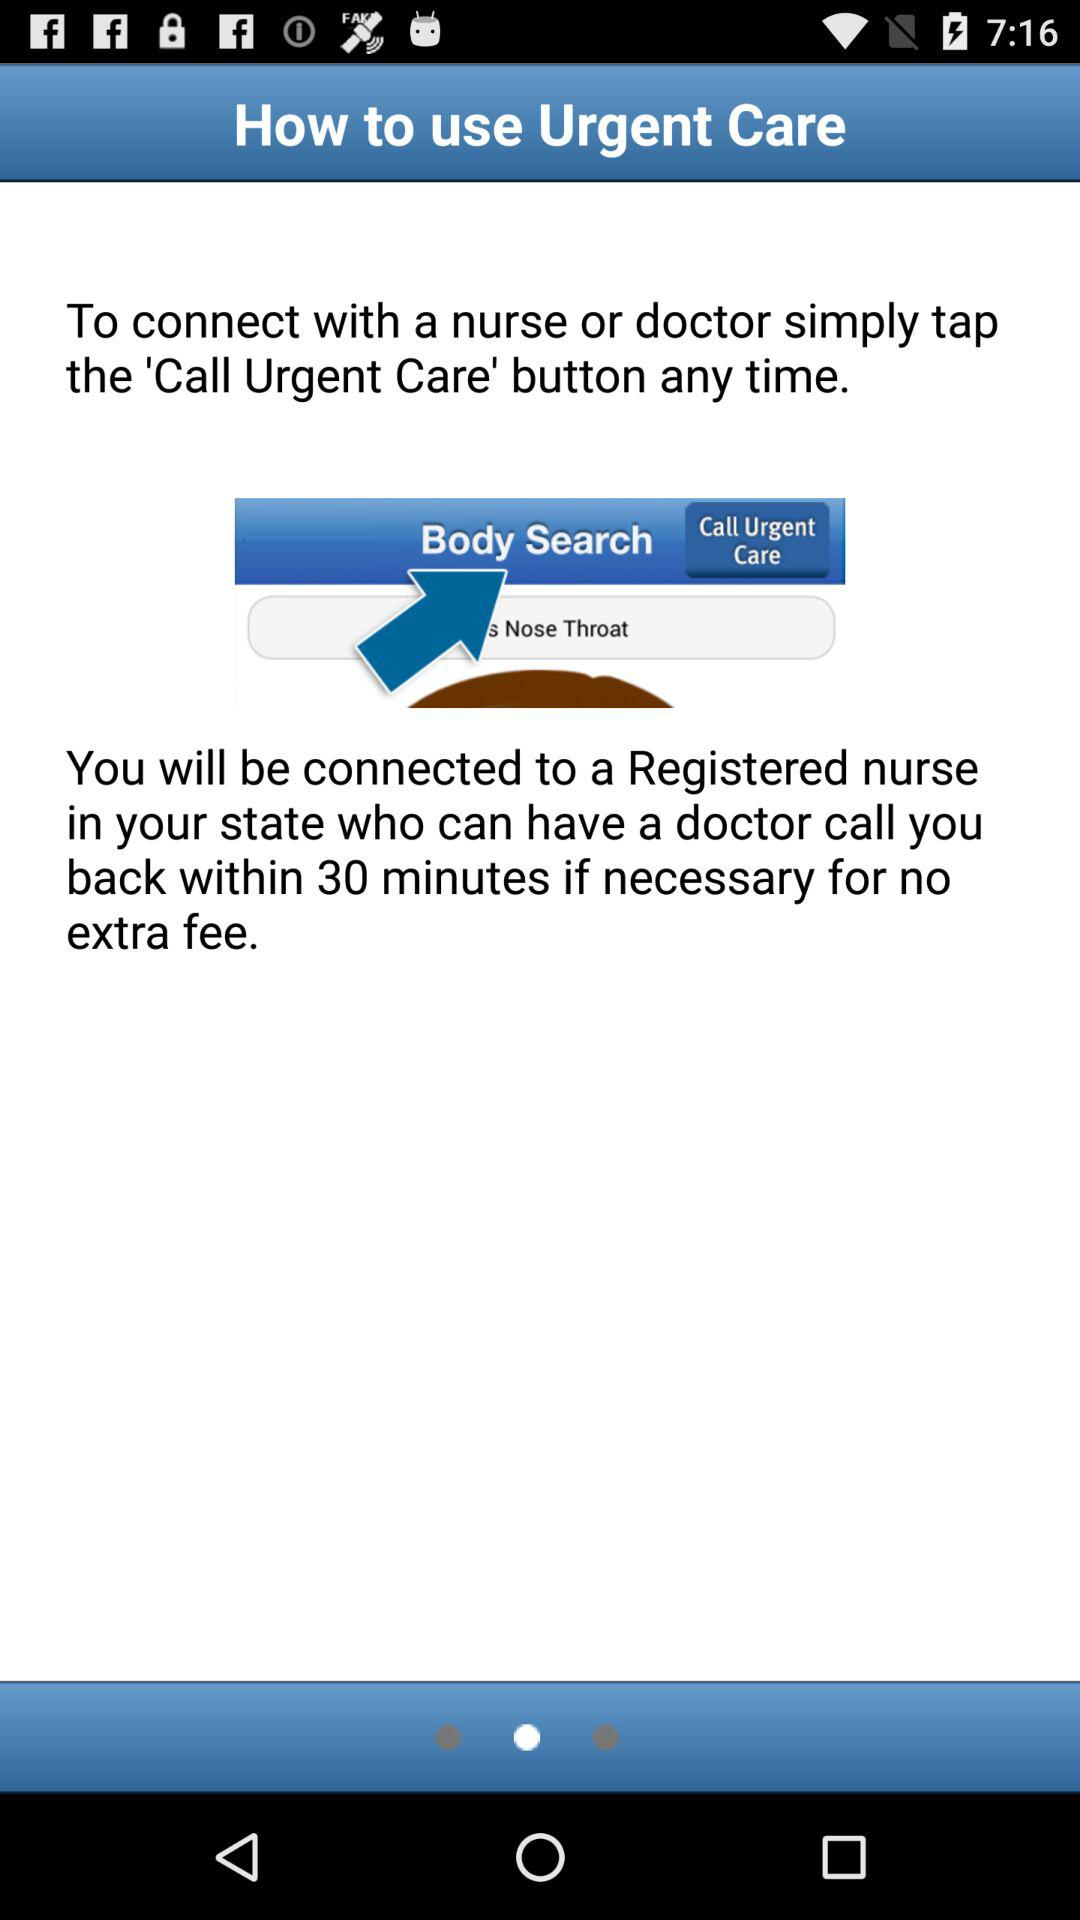What is the app name? The app name is "Urgent Care". 